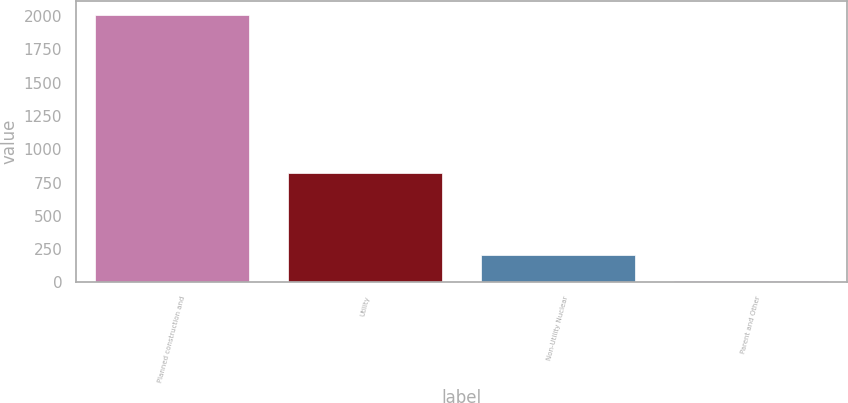<chart> <loc_0><loc_0><loc_500><loc_500><bar_chart><fcel>Planned construction and<fcel>Utility<fcel>Non-Utility Nuclear<fcel>Parent and Other<nl><fcel>2012<fcel>822<fcel>208.4<fcel>8<nl></chart> 